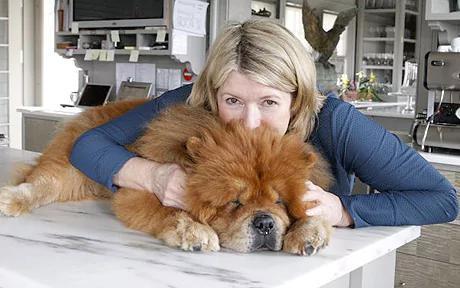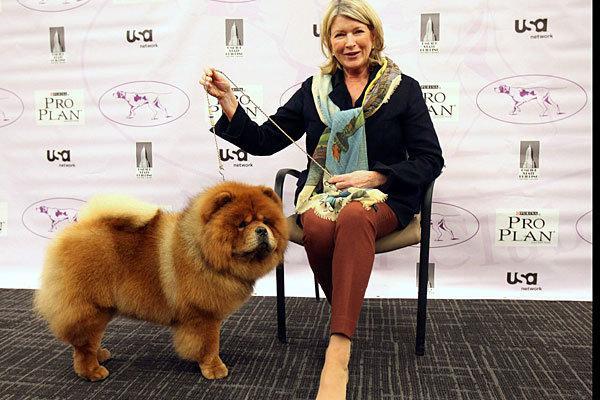The first image is the image on the left, the second image is the image on the right. Evaluate the accuracy of this statement regarding the images: "The left image features a person holding at least two chow puppies in front of their chest.". Is it true? Answer yes or no. No. The first image is the image on the left, the second image is the image on the right. Given the left and right images, does the statement "A person is holding at least two fluffy Chow Chow puppies in the image on the left." hold true? Answer yes or no. No. 